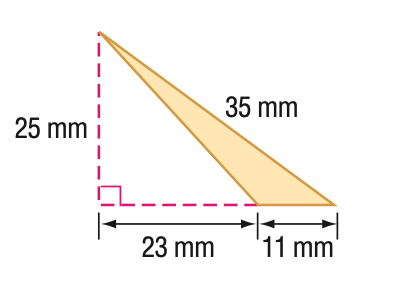Answer the mathemtical geometry problem and directly provide the correct option letter.
Question: Find the area of the triangle. Round to the nearest tenth if necessary.
Choices: A: 137.5 B: 150 C: 265 D: 287.5 A 